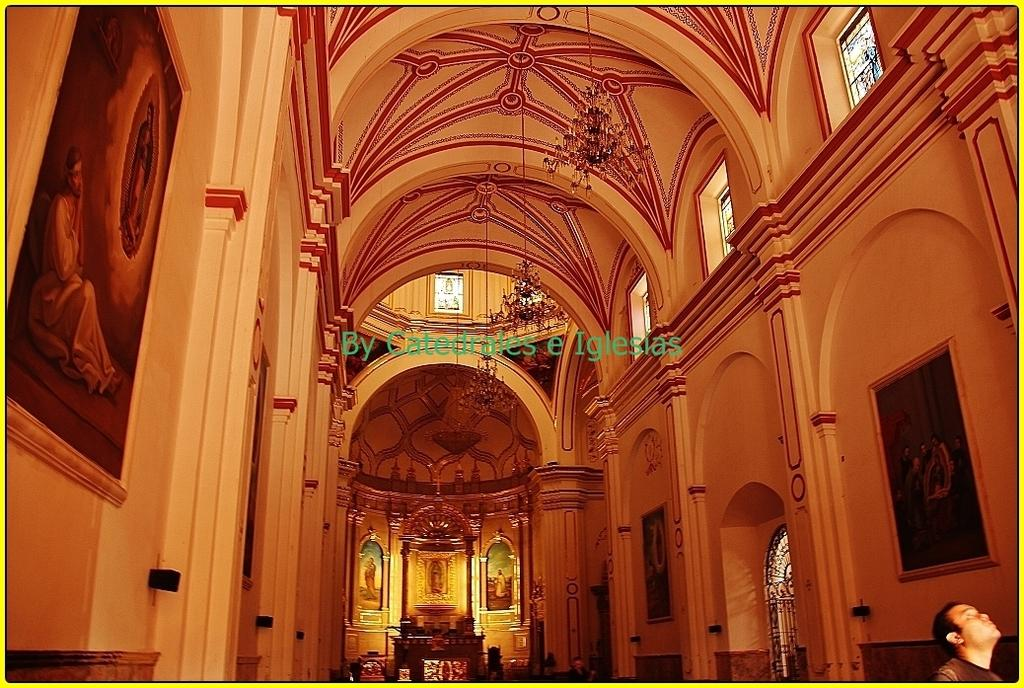Where was the image taken? The image was taken indoors. What can be seen on the left side of the image? There are photo frames on the left side of the image. What can be seen on the right side of the image? There are photo frames on the right side of the image. What is located in the middle of the image? There are lights in the middle of the image. Is there anyone visible in the image? Yes, there is a person in the bottom right corner of the image. How many spiders are crawling on the photo frames in the image? There are no spiders visible in the image; it only shows photo frames, lights, and a person. What type of bears can be seen interacting with the lights in the image? There are no bears present in the image; it only shows photo frames, lights, and a person. 